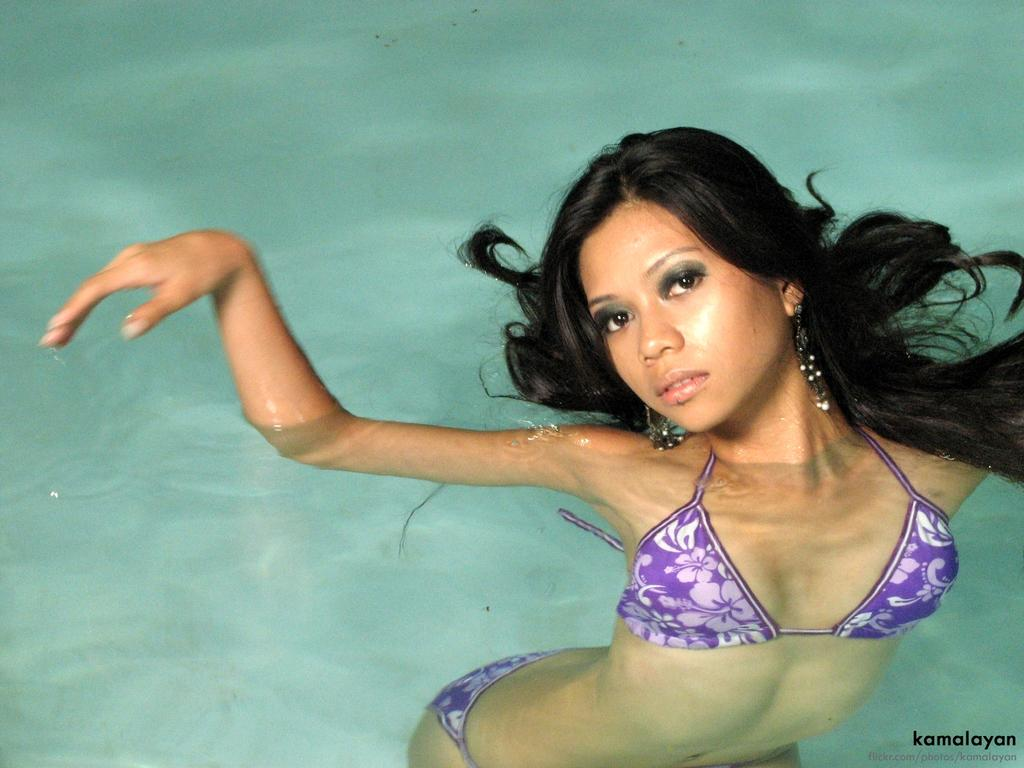Who is in the image? There is a woman in the image. What is the woman doing in the image? The woman is swimming in the water and posing for a photo. What is the primary element in which the woman is situated? The woman is swimming in water, which might be in a swimming pool. What type of bag is the woman carrying while swimming in the image? There is no bag visible in the image; the woman is swimming and posing for a photo in the water. 